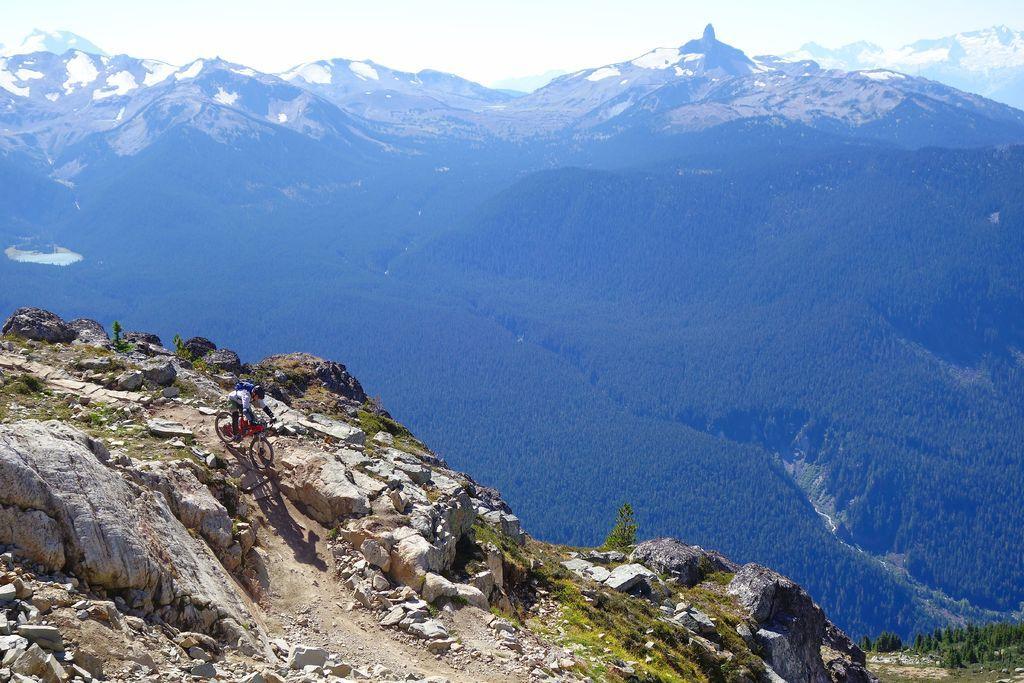Describe this image in one or two sentences. In this image in the front there are stones and there is a person riding a bicycle. In the background there are trees, mountains and on the right side there's grass on the ground. 